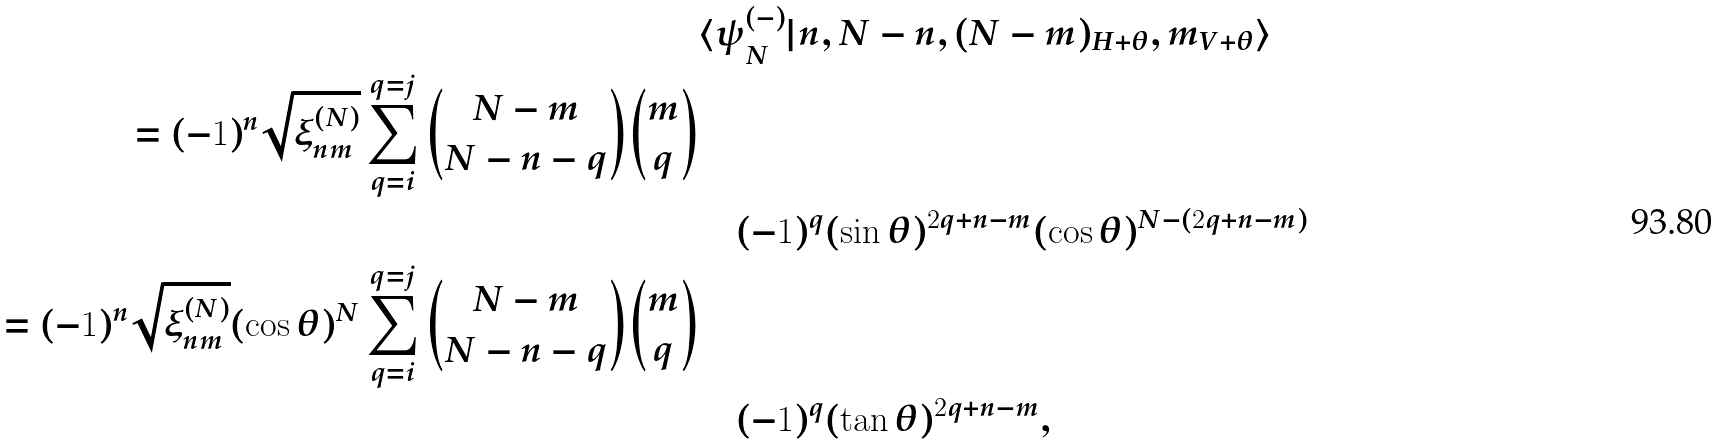Convert formula to latex. <formula><loc_0><loc_0><loc_500><loc_500>& \langle \psi ^ { ( - ) } _ { N } | n , N - n , ( N - m ) _ { H + \theta } , m _ { V + \theta } \rangle \\ = ( - 1 ) ^ { n } \sqrt { \xi _ { n m } ^ { ( N ) } } \sum _ { q = i } ^ { q = j } \binom { N - m } { N - n - q } \binom { m } { q } \\ & \quad ( - 1 ) ^ { q } ( \sin { \theta } ) ^ { 2 q + n - m } ( \cos { \theta } ) ^ { N - ( 2 q + n - m ) } \\ = ( - 1 ) ^ { n } \sqrt { \xi _ { n m } ^ { ( N ) } } ( \cos { \theta } ) ^ { N } \sum _ { q = i } ^ { q = j } \binom { N - m } { N - n - q } \binom { m } { q } \\ & \quad ( - 1 ) ^ { q } ( \tan { \theta } ) ^ { 2 q + n - m } ,</formula> 